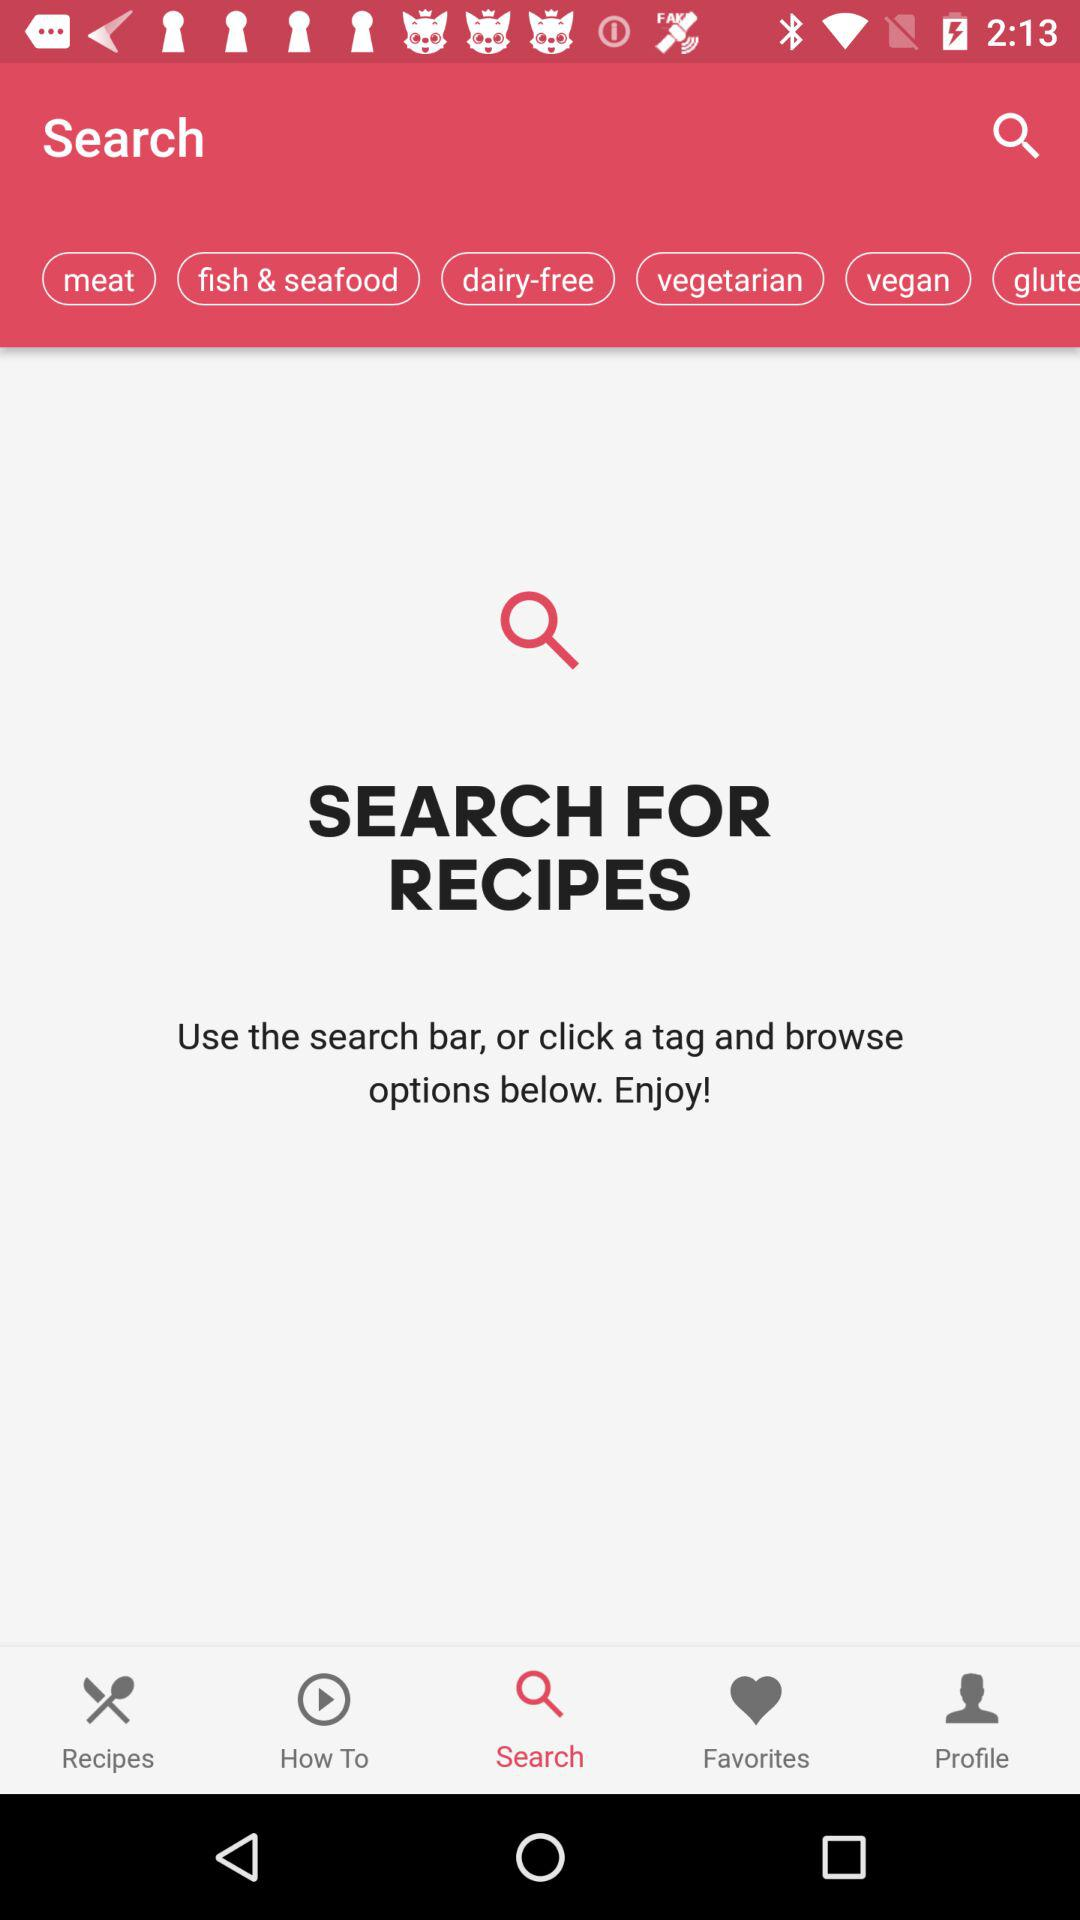Which tab is selected? The selected tab is search. 